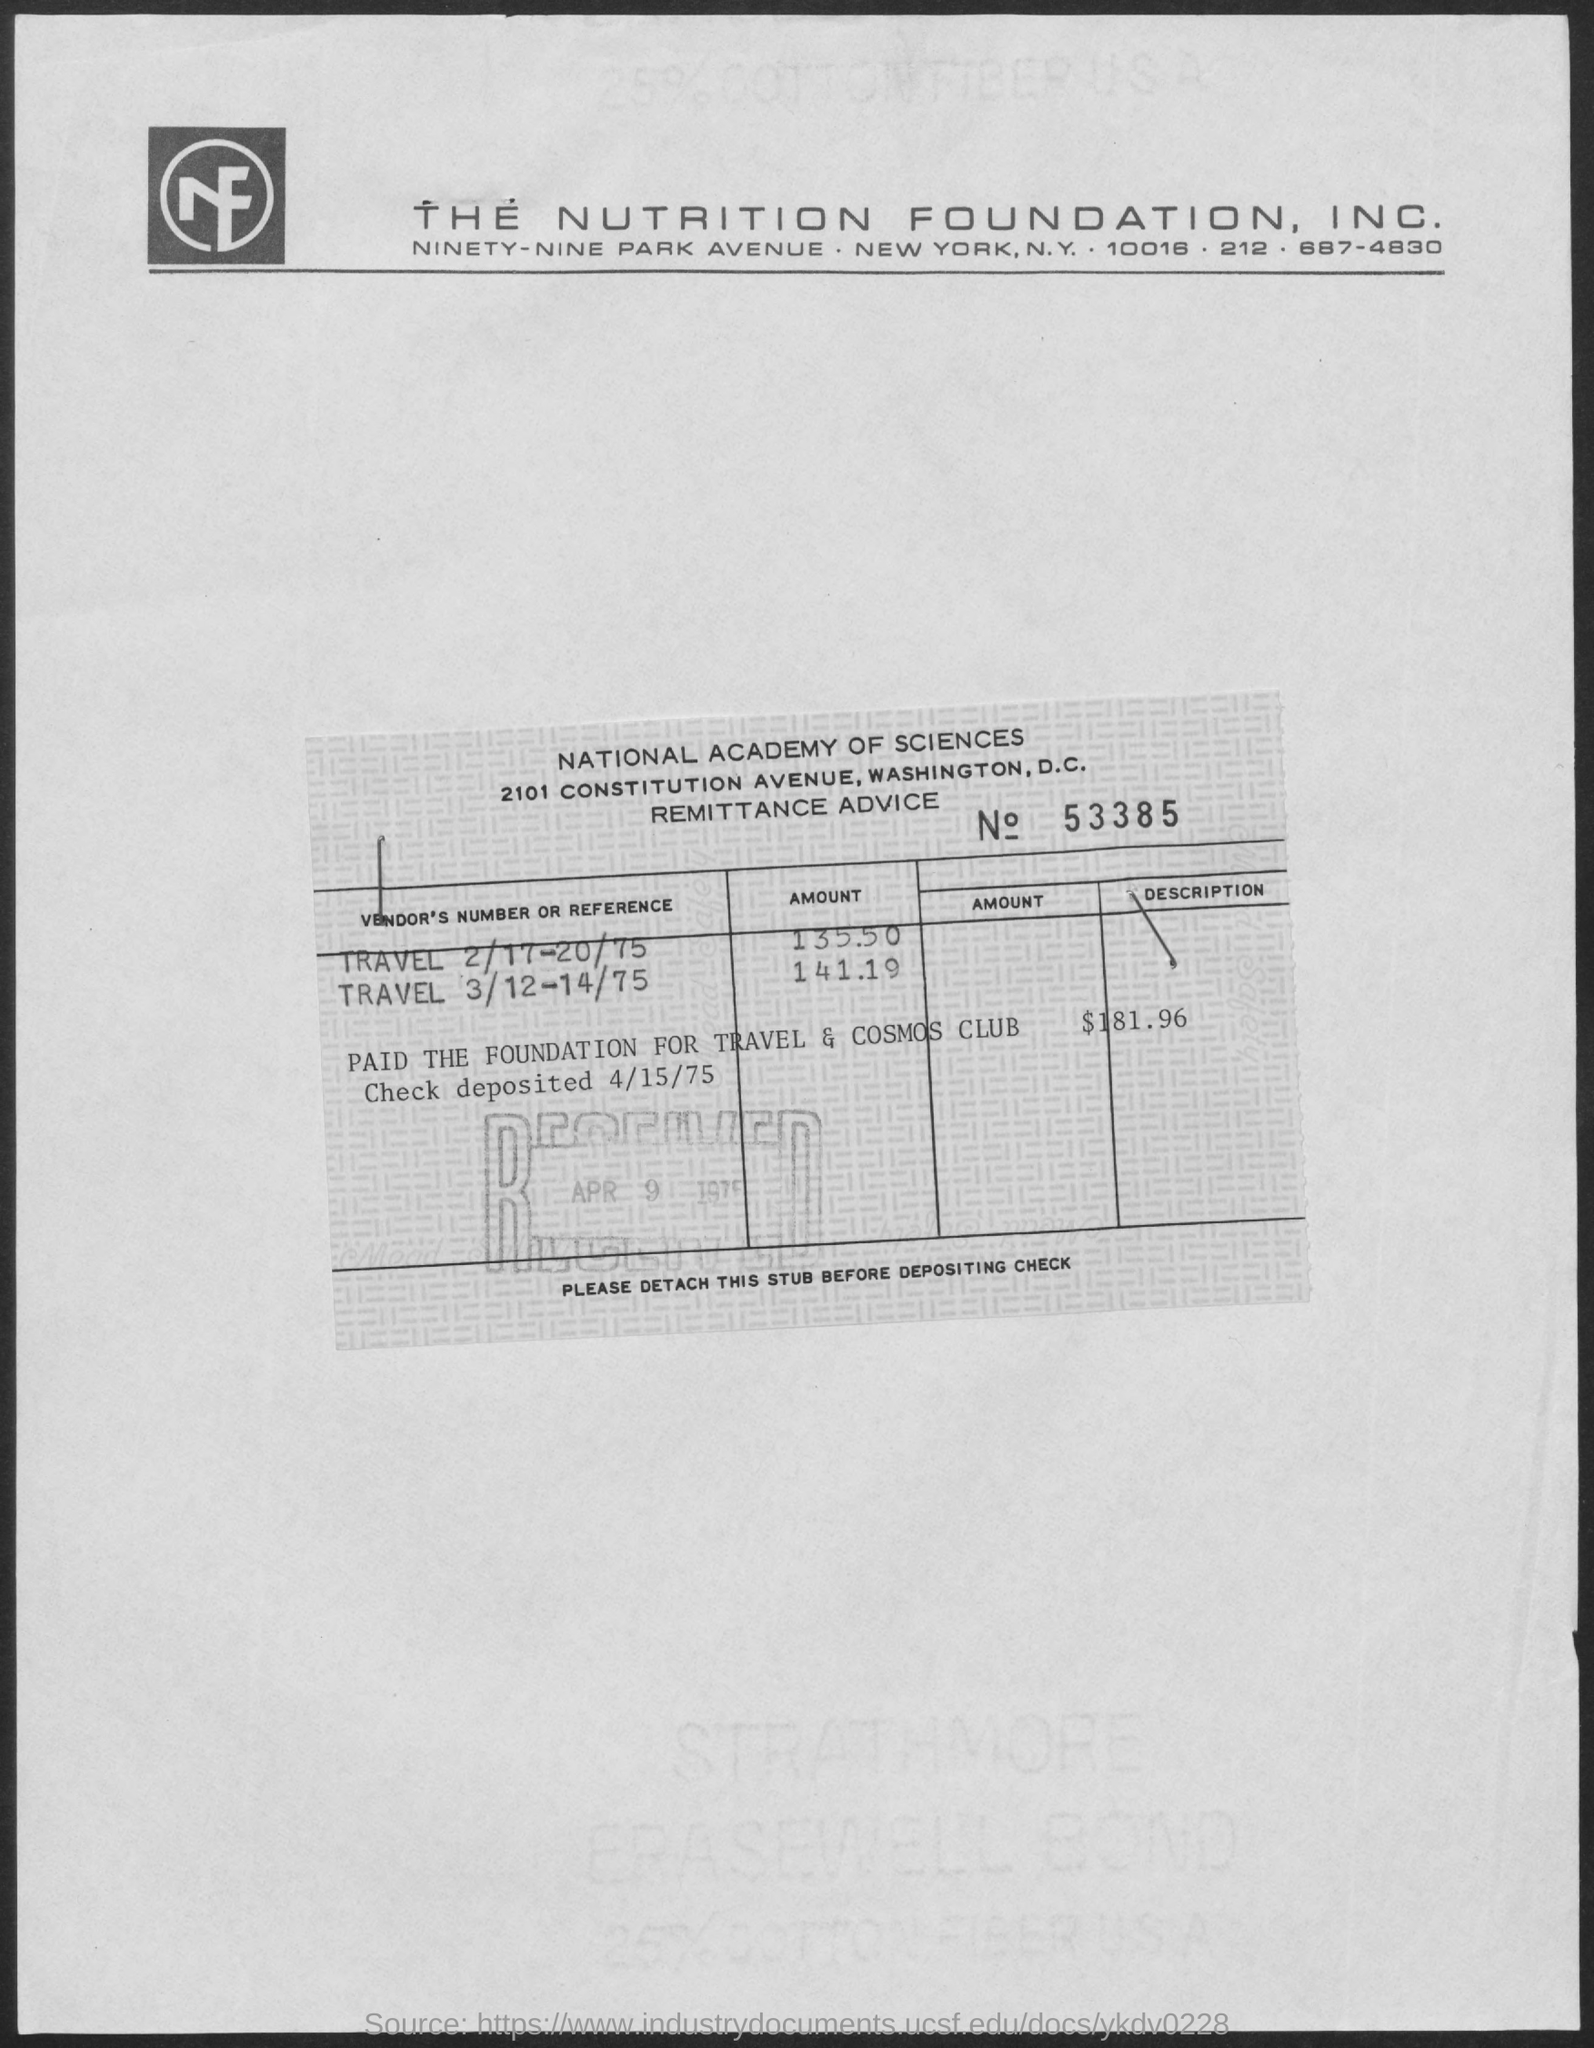What is the title of the document ?
Your answer should be compact. THE NUTRITION FOUNDATION, INC. 